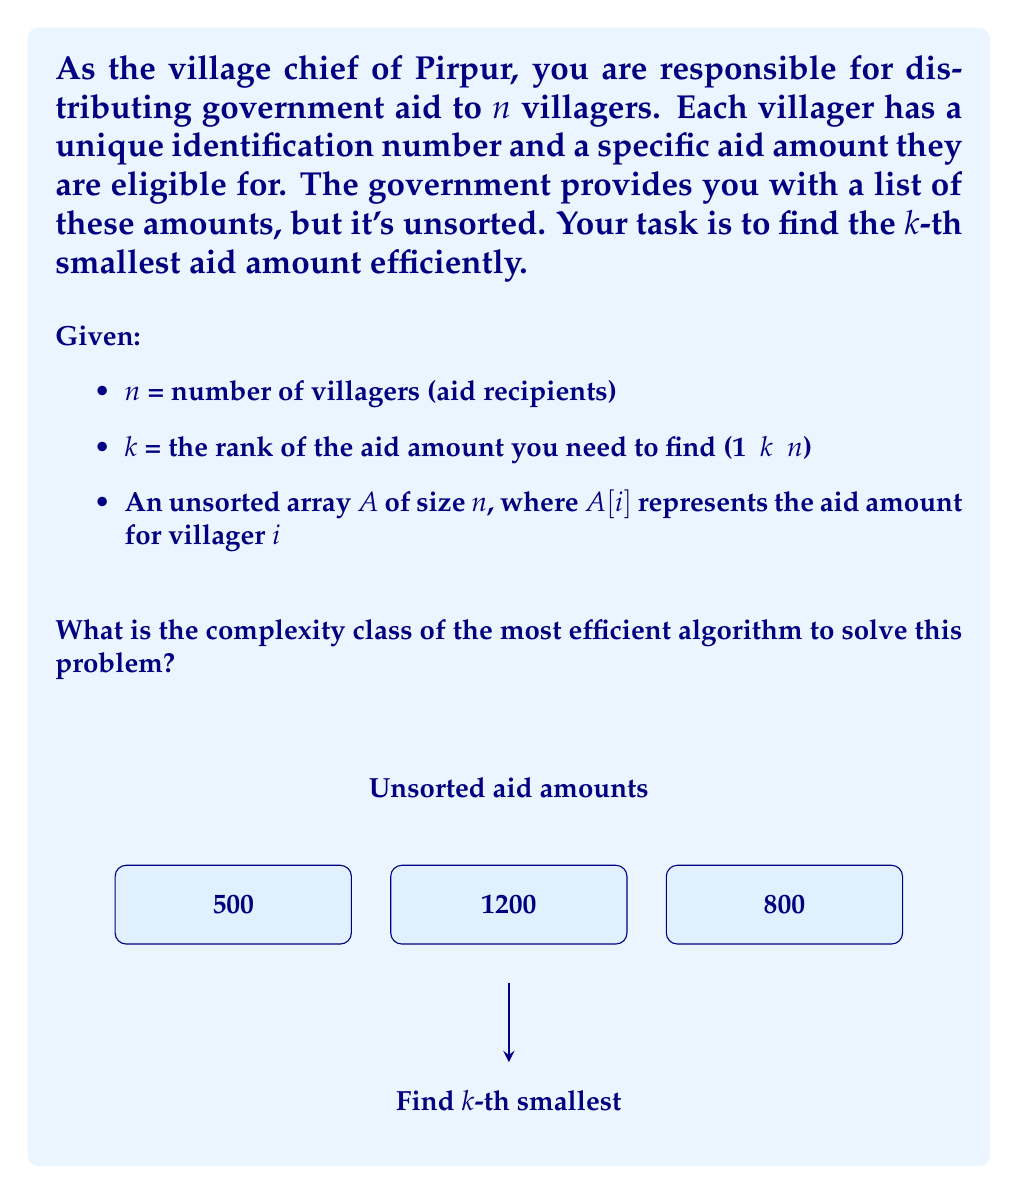Show me your answer to this math problem. To solve this problem efficiently, we can use the QuickSelect algorithm, which is an optimized version of QuickSort. Here's the step-by-step analysis:

1) The QuickSelect algorithm works by recursively partitioning the array around a pivot element.

2) In each iteration, it eliminates roughly half of the remaining elements, similar to binary search.

3) The average-case time complexity of QuickSelect is $O(n)$, where $n$ is the number of elements in the array.

4) The worst-case time complexity is $O(n^2)$, but this occurs rarely and can be mitigated by choosing the pivot randomly.

5) The space complexity is $O(1)$ as it can be implemented in-place.

6) Comparing this with other sorting algorithms:
   - Full sorting (e.g., QuickSort, MergeSort) would take $O(n \log n)$ time.
   - Using a min-heap would take $O(n + k \log n)$ time.

7) The QuickSelect algorithm is optimal for this problem, achieving linear time complexity on average.

8) This places the problem in the complexity class P (Polynomial time).

9) More specifically, it belongs to the subclass of linear time algorithms within P.

Therefore, the most efficient algorithm for this problem falls into the complexity class P, with an average-case time complexity of $O(n)$.
Answer: P (Polynomial time) 